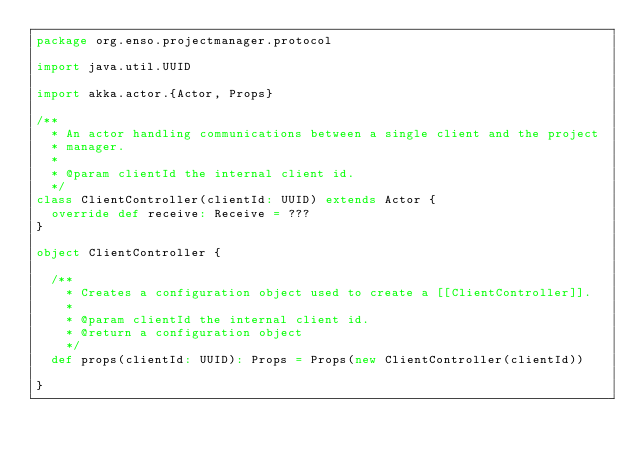<code> <loc_0><loc_0><loc_500><loc_500><_Scala_>package org.enso.projectmanager.protocol

import java.util.UUID

import akka.actor.{Actor, Props}

/**
  * An actor handling communications between a single client and the project
  * manager.
  *
  * @param clientId the internal client id.
  */
class ClientController(clientId: UUID) extends Actor {
  override def receive: Receive = ???
}

object ClientController {

  /**
    * Creates a configuration object used to create a [[ClientController]].
    *
    * @param clientId the internal client id.
    * @return a configuration object
    */
  def props(clientId: UUID): Props = Props(new ClientController(clientId))

}
</code> 